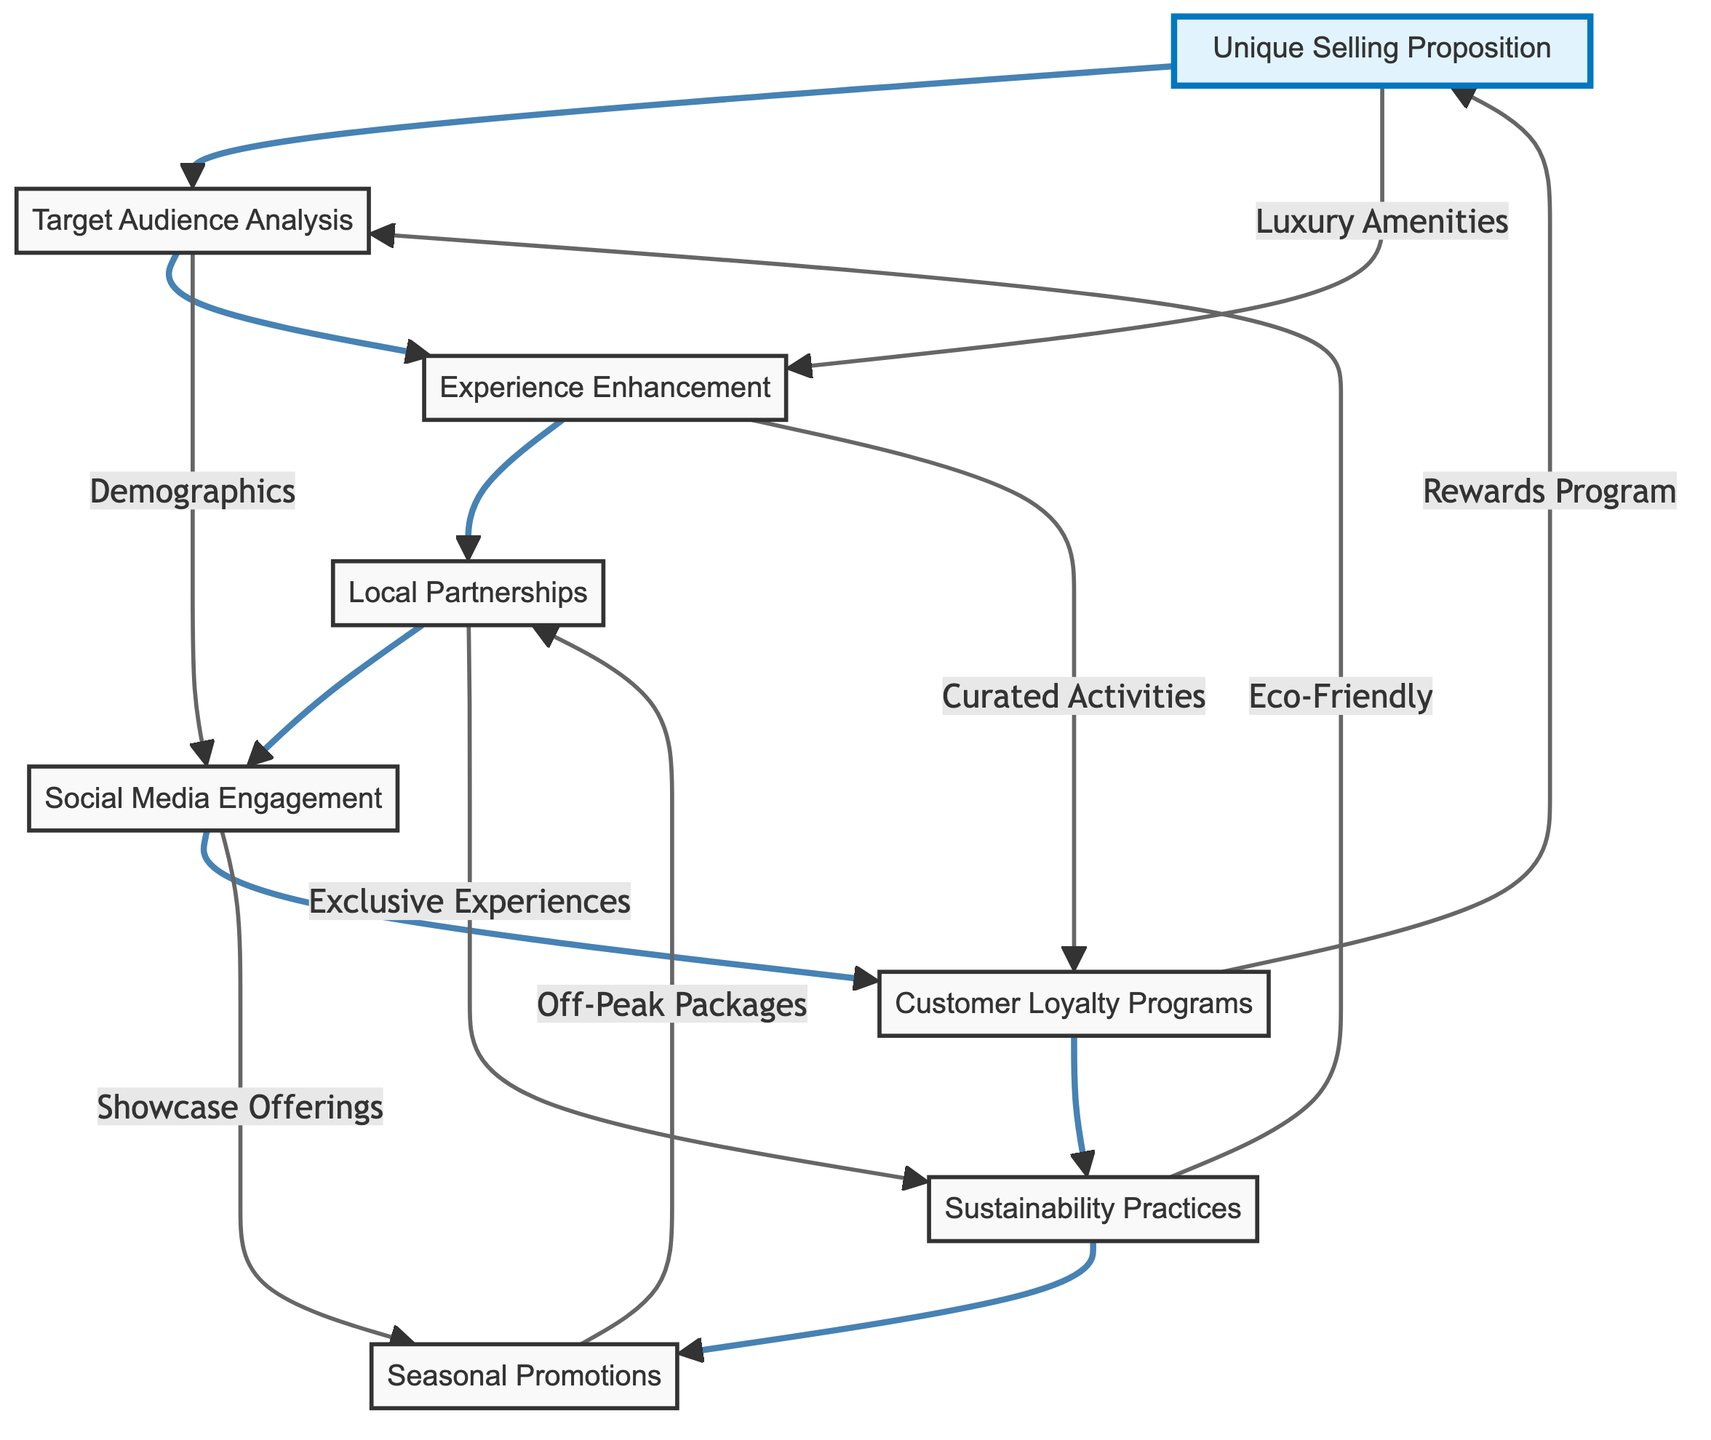What is the first node in the flow chart? The first node in the flow chart is "Unique Selling Proposition." It is positioned at the top and serves as the starting point for the marketing strategies.
Answer: Unique Selling Proposition How many nodes are there in total? The flow chart contains a total of eight nodes, representing different marketing strategies for traditional resorts. By counting each node listed, we confirm their total.
Answer: 8 Which node follows "Target Audience Analysis"? The node that follows "Target Audience Analysis" is "Experience Enhancement." This is determined by examining the flow from one node to the next as indicated by the arrows in the diagram.
Answer: Experience Enhancement What is the relationship between "Local Partnerships" and "Sustainability Practices"? "Local Partnerships" leads to "Sustainability Practices" indirectly through the flow of connections, where both are part of a marketing strategy sequence, enhancing resort offerings and promoting eco-friendly practices respectively.
Answer: Indirect relationship What type of activities does "Experience Enhancement" promise? "Experience Enhancement" promises curated activities such as fine dining, spa retreats, and adventure experiences. This information is drawn directly from the description of the respective node in the diagram.
Answer: Curated activities How does "Social Media Engagement" connect to "Customer Loyalty Programs"? "Social Media Engagement" connects to "Customer Loyalty Programs" through the flow that showcases unique resort offerings and guest experiences, thereby encouraging repeat visits and creating loyalty among customers.
Answer: Through showcasing experiences What is one strategy that targets eco-conscious travelers? One strategy that targets eco-conscious travelers is "Sustainability Practices." The node explicitly outlines this focus on environmentally friendly practices aimed at attracting this demographic.
Answer: Sustainability Practices Which node has a direct link to "Seasonal Promotions"? The node with a direct link to "Seasonal Promotions" is "Local Partnerships." The connection indicates that developing special packages during off-peak seasons is influenced by collaborating with local businesses for exclusive guest experiences.
Answer: Local Partnerships 